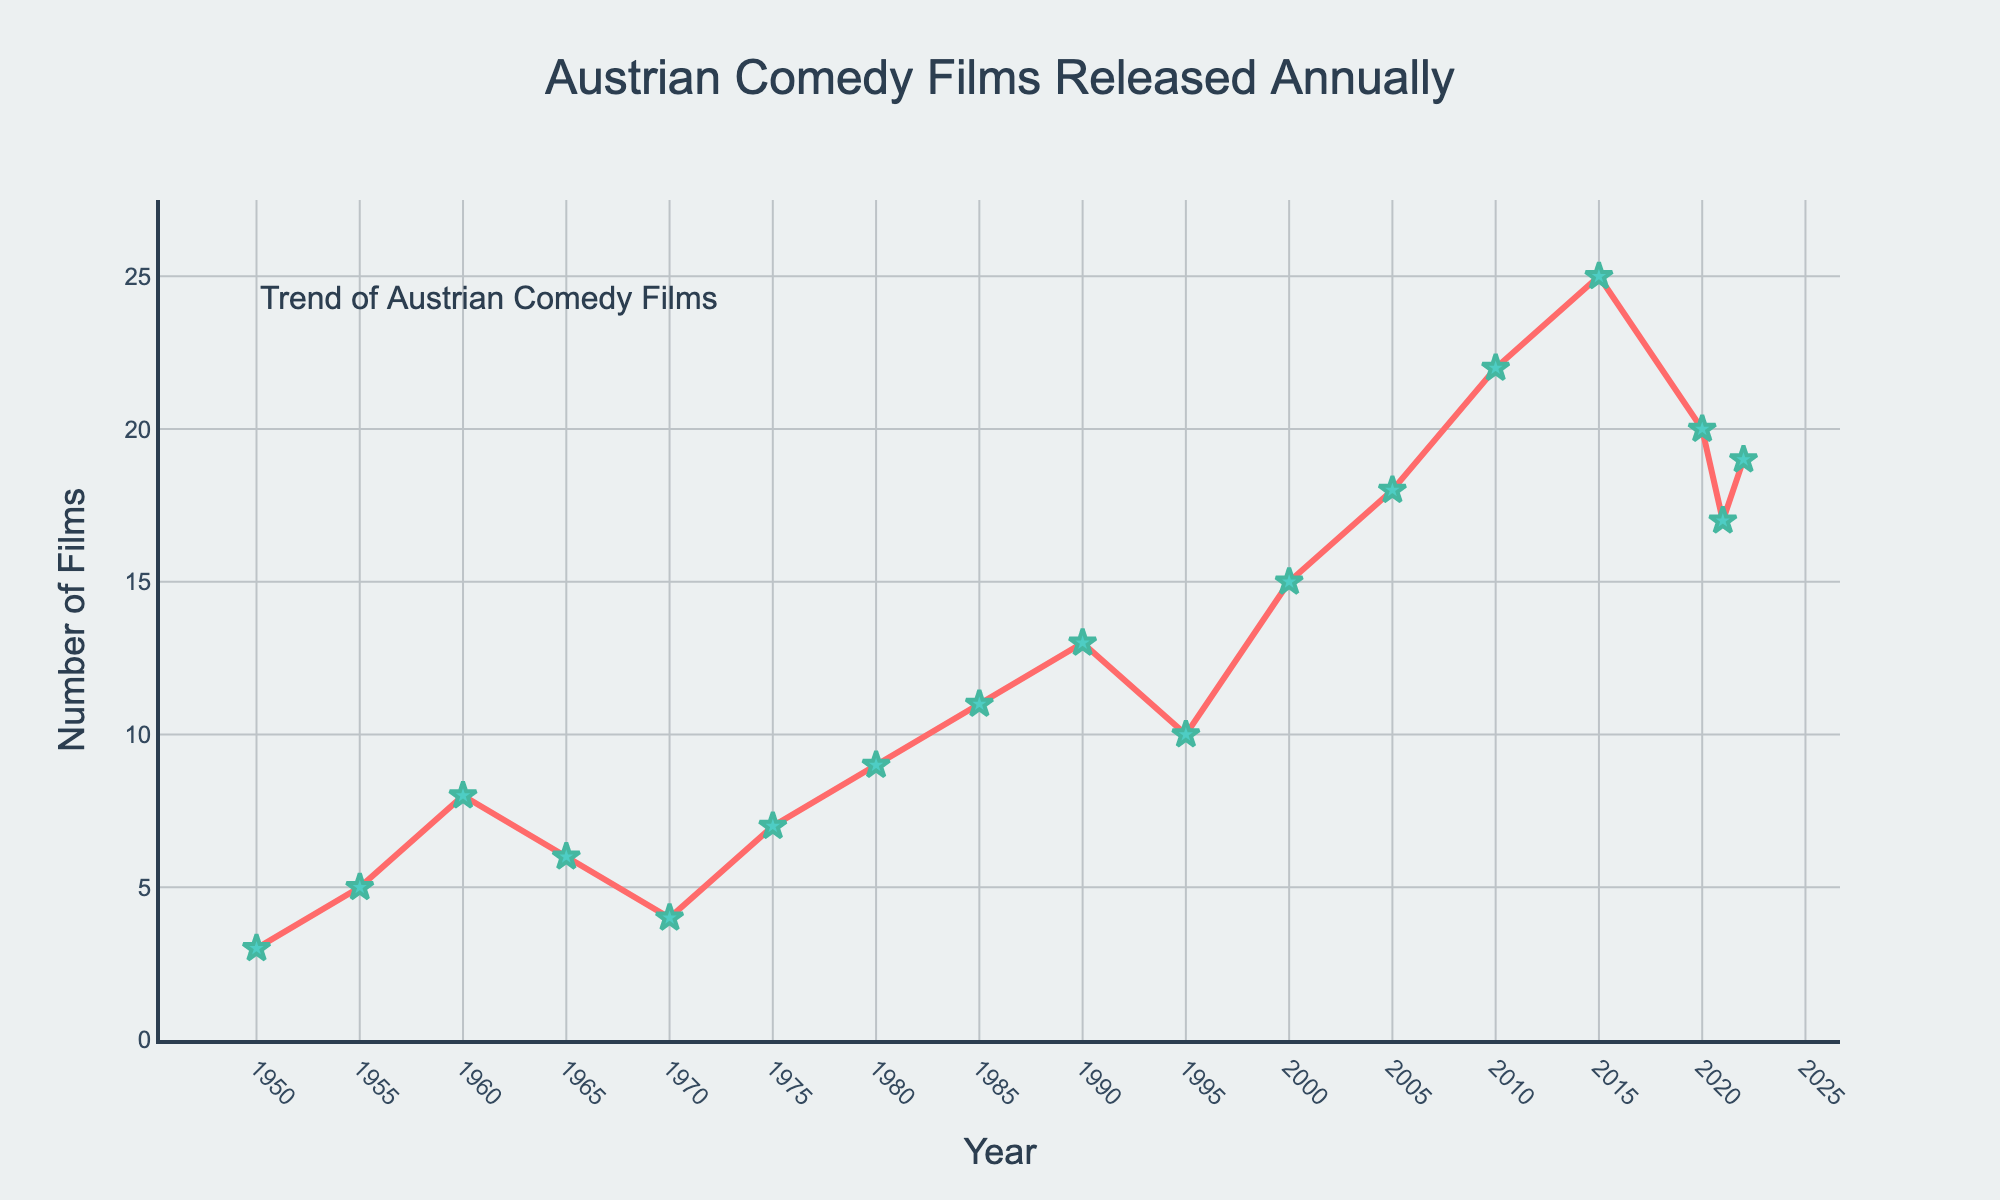What was the trend of Austrian comedy films released annually between 1950 and 2022? To identify the trend, observe the overall progression of the values on the chart from 1950 to 2022. The general pattern shows an initial slow increase, peaking around 2015 and then a decline towards 2022.
Answer: Increasing with some fluctuations and a peak around 2015 What is the difference in the number of comedy films released in 1980 and 2020? Refer to the specific data points for each year. In 1980, there were 9 films released, and in 2020, there were 20 films released. Subtract the smaller number from the larger number to find the difference: 20 - 9.
Answer: 11 During which year did the number of Austrian comedy films released reach its maximum, and what was the number? Look for the highest point on the line chart. The peak number of films released, which is 25, occurs in 2015.
Answer: 2015, 25 Compare the number of films released in 1995 and 2021. Which year had more films, and by how many? Find the values on the chart. In 1995, there were 10 films released, and in 2021, there were 17 films released. Subtract the smaller number from the larger number to find the difference: 17 - 10.
Answer: 2021 by 7 more films What is the average number of Austrian comedy films released per year from 2000 to 2022? Add the numbers for each year from 2000 to 2022 (15, 18, 22, 25, 20, 17, 19) and divide the sum by the number of years (7). The total is 136, so the average is 136 / 7.
Answer: 19.4 How did the number of comedy films released change from 2005 to 2010? Refer to the data points for these years. In 2005, there were 18 films released, and in 2010, there were 22. Subtract the number in 2005 from the number in 2010: 22 - 18.
Answer: Increased by 4 During which decade did the number of comedy films released show the most significant increase? Compare the differences in the number of films released at the start and end of each decade. The biggest increase is from 2000 to 2010 (from 18 to 22), a difference of 4.
Answer: 2000-2010 Calculate the sum of comedy films released from 1950 to 1970. Add the values from each year within this range (3, 5, 8, 6, 4). The total is 3 + 5 + 8 + 6 + 4.
Answer: 26 What was the general visual trend observed between 1990 and 2020? The chart shows a recurring upward pattern, increasing from 13 in 1990 to a peak of 25 in 2015 before dropping slightly to 20 in 2020.
Answer: Overall increase with some fluctuations 